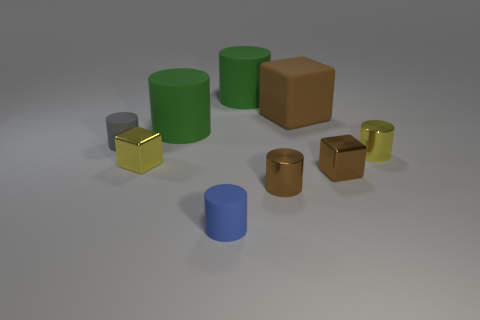The large block has what color?
Your answer should be compact. Brown. Are there any large rubber spheres?
Ensure brevity in your answer.  No. There is a brown shiny block; are there any brown cubes in front of it?
Offer a terse response. No. There is a gray thing that is the same shape as the blue matte object; what is its material?
Give a very brief answer. Rubber. Are there any other things that have the same material as the small blue cylinder?
Your answer should be very brief. Yes. How many other things are there of the same shape as the gray matte thing?
Give a very brief answer. 5. How many gray objects are behind the rubber cube on the right side of the matte cylinder that is in front of the tiny yellow shiny block?
Provide a succinct answer. 0. What number of large green rubber things have the same shape as the gray object?
Provide a short and direct response. 2. There is a small matte cylinder in front of the tiny gray cylinder; is its color the same as the large block?
Ensure brevity in your answer.  No. What is the shape of the brown metallic thing that is behind the small brown cylinder to the left of the brown thing behind the small yellow cylinder?
Provide a short and direct response. Cube. 